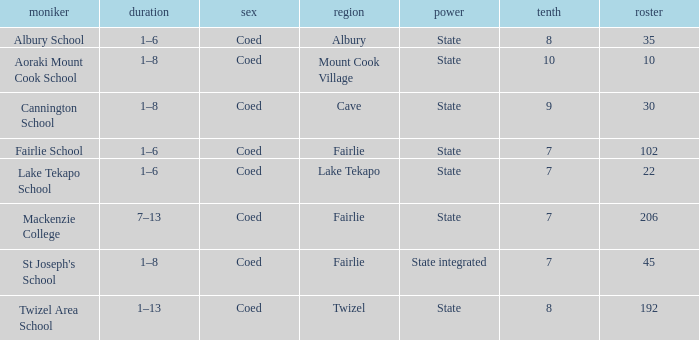What area is named Mackenzie college? Fairlie. 